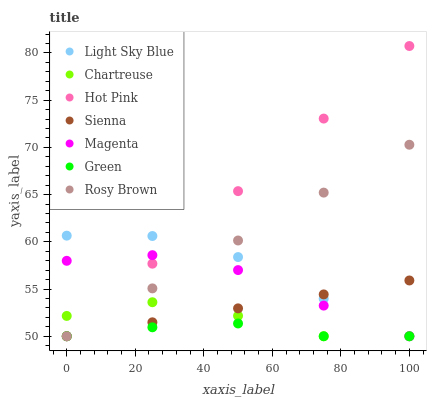Does Green have the minimum area under the curve?
Answer yes or no. Yes. Does Hot Pink have the maximum area under the curve?
Answer yes or no. Yes. Does Sienna have the minimum area under the curve?
Answer yes or no. No. Does Sienna have the maximum area under the curve?
Answer yes or no. No. Is Rosy Brown the smoothest?
Answer yes or no. Yes. Is Chartreuse the roughest?
Answer yes or no. Yes. Is Hot Pink the smoothest?
Answer yes or no. No. Is Hot Pink the roughest?
Answer yes or no. No. Does Rosy Brown have the lowest value?
Answer yes or no. Yes. Does Hot Pink have the highest value?
Answer yes or no. Yes. Does Sienna have the highest value?
Answer yes or no. No. Does Hot Pink intersect Magenta?
Answer yes or no. Yes. Is Hot Pink less than Magenta?
Answer yes or no. No. Is Hot Pink greater than Magenta?
Answer yes or no. No. 